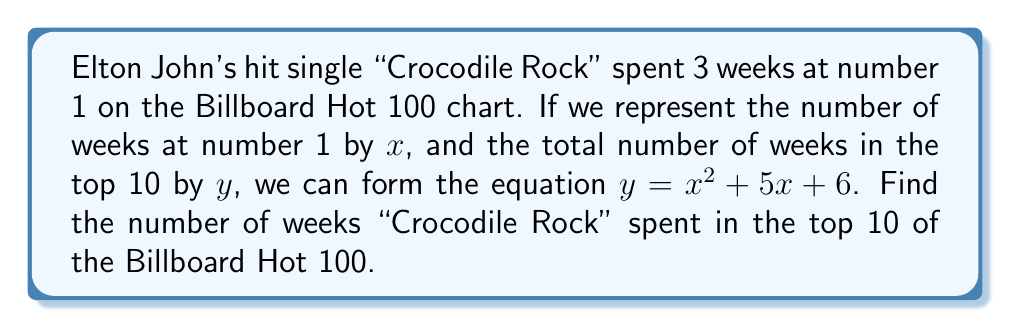Teach me how to tackle this problem. To solve this problem, we need to follow these steps:

1) We know that $x = 3$ (weeks at number 1).

2) We need to substitute this value into the equation:
   $y = x^2 + 5x + 6$

3) Let's calculate:
   $y = 3^2 + 5(3) + 6$
   $y = 9 + 15 + 6$
   $y = 30$

4) Therefore, "Crocodile Rock" spent 30 weeks in the top 10 of the Billboard Hot 100.

Alternatively, we can view this as finding the y-coordinate of a point on the quadratic function $f(x) = x^2 + 5x + 6$ when $x = 3$. This interpretation aligns with the graph of the song's chart performance over time.
Answer: 30 weeks 